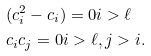Convert formula to latex. <formula><loc_0><loc_0><loc_500><loc_500>& ( c _ { i } ^ { 2 } - c _ { i } ) = 0 i > \ell \\ & c _ { i } c _ { j } = 0 i > \ell , j > i .</formula> 